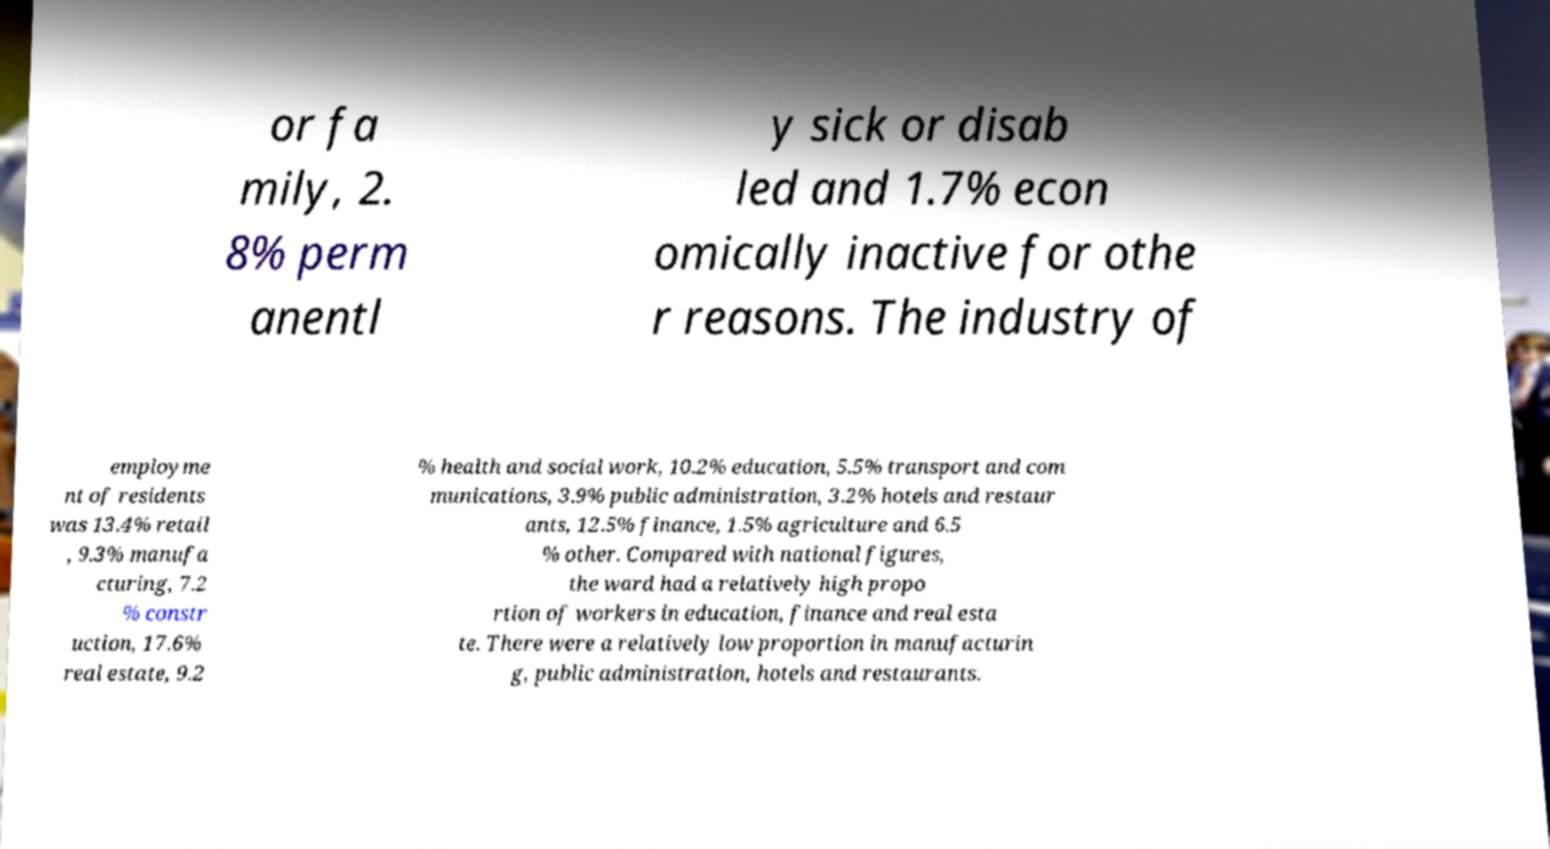What messages or text are displayed in this image? I need them in a readable, typed format. or fa mily, 2. 8% perm anentl y sick or disab led and 1.7% econ omically inactive for othe r reasons. The industry of employme nt of residents was 13.4% retail , 9.3% manufa cturing, 7.2 % constr uction, 17.6% real estate, 9.2 % health and social work, 10.2% education, 5.5% transport and com munications, 3.9% public administration, 3.2% hotels and restaur ants, 12.5% finance, 1.5% agriculture and 6.5 % other. Compared with national figures, the ward had a relatively high propo rtion of workers in education, finance and real esta te. There were a relatively low proportion in manufacturin g, public administration, hotels and restaurants. 